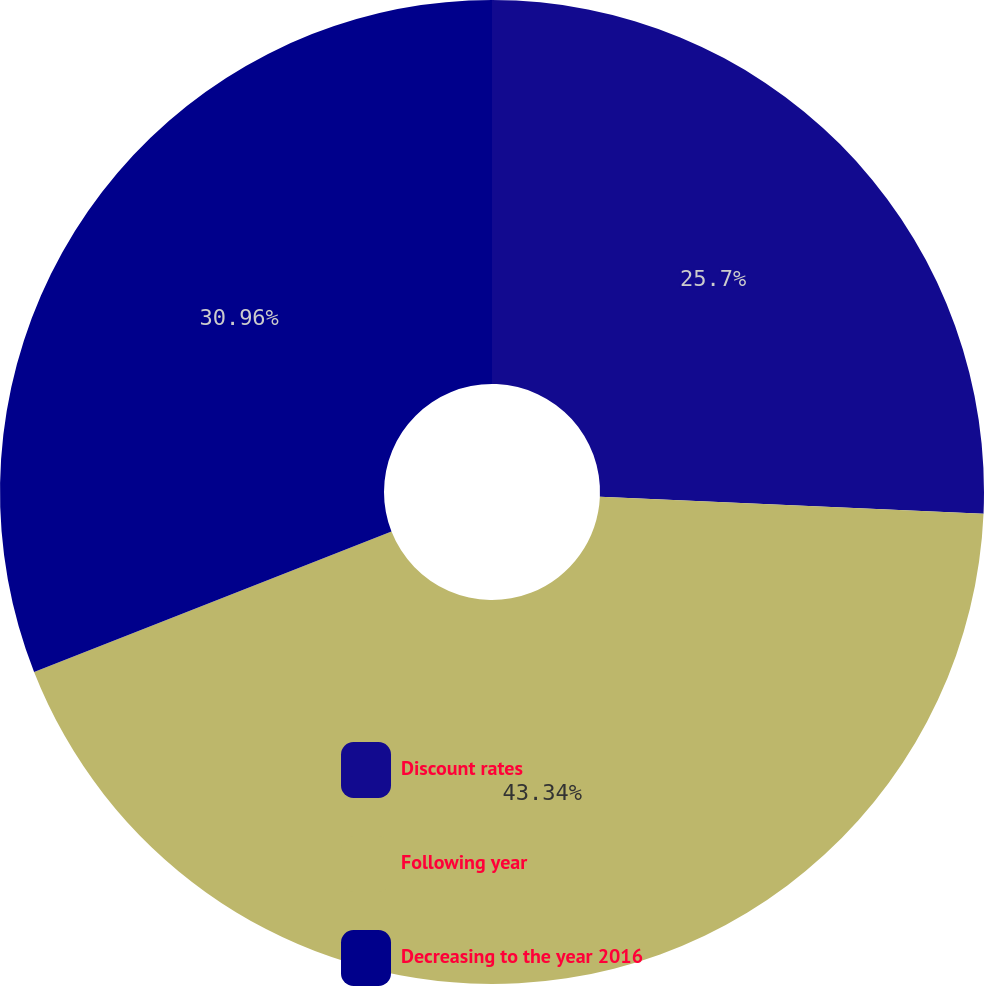Convert chart to OTSL. <chart><loc_0><loc_0><loc_500><loc_500><pie_chart><fcel>Discount rates<fcel>Following year<fcel>Decreasing to the year 2016<nl><fcel>25.7%<fcel>43.34%<fcel>30.96%<nl></chart> 